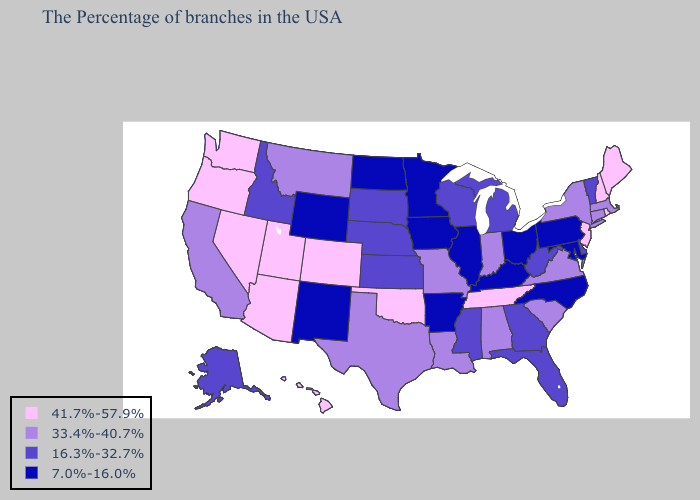Among the states that border Florida , which have the highest value?
Short answer required. Alabama. Does Ohio have the highest value in the USA?
Keep it brief. No. What is the lowest value in the USA?
Be succinct. 7.0%-16.0%. Which states have the lowest value in the USA?
Quick response, please. Maryland, Pennsylvania, North Carolina, Ohio, Kentucky, Illinois, Arkansas, Minnesota, Iowa, North Dakota, Wyoming, New Mexico. Does New Hampshire have the same value as Nevada?
Keep it brief. Yes. What is the value of South Carolina?
Write a very short answer. 33.4%-40.7%. Does the map have missing data?
Quick response, please. No. Is the legend a continuous bar?
Short answer required. No. Does North Carolina have the lowest value in the USA?
Answer briefly. Yes. Name the states that have a value in the range 16.3%-32.7%?
Answer briefly. Vermont, Delaware, West Virginia, Florida, Georgia, Michigan, Wisconsin, Mississippi, Kansas, Nebraska, South Dakota, Idaho, Alaska. What is the value of Mississippi?
Concise answer only. 16.3%-32.7%. What is the lowest value in the Northeast?
Concise answer only. 7.0%-16.0%. Is the legend a continuous bar?
Concise answer only. No. Among the states that border Florida , does Georgia have the lowest value?
Give a very brief answer. Yes. Does Louisiana have the highest value in the USA?
Short answer required. No. 